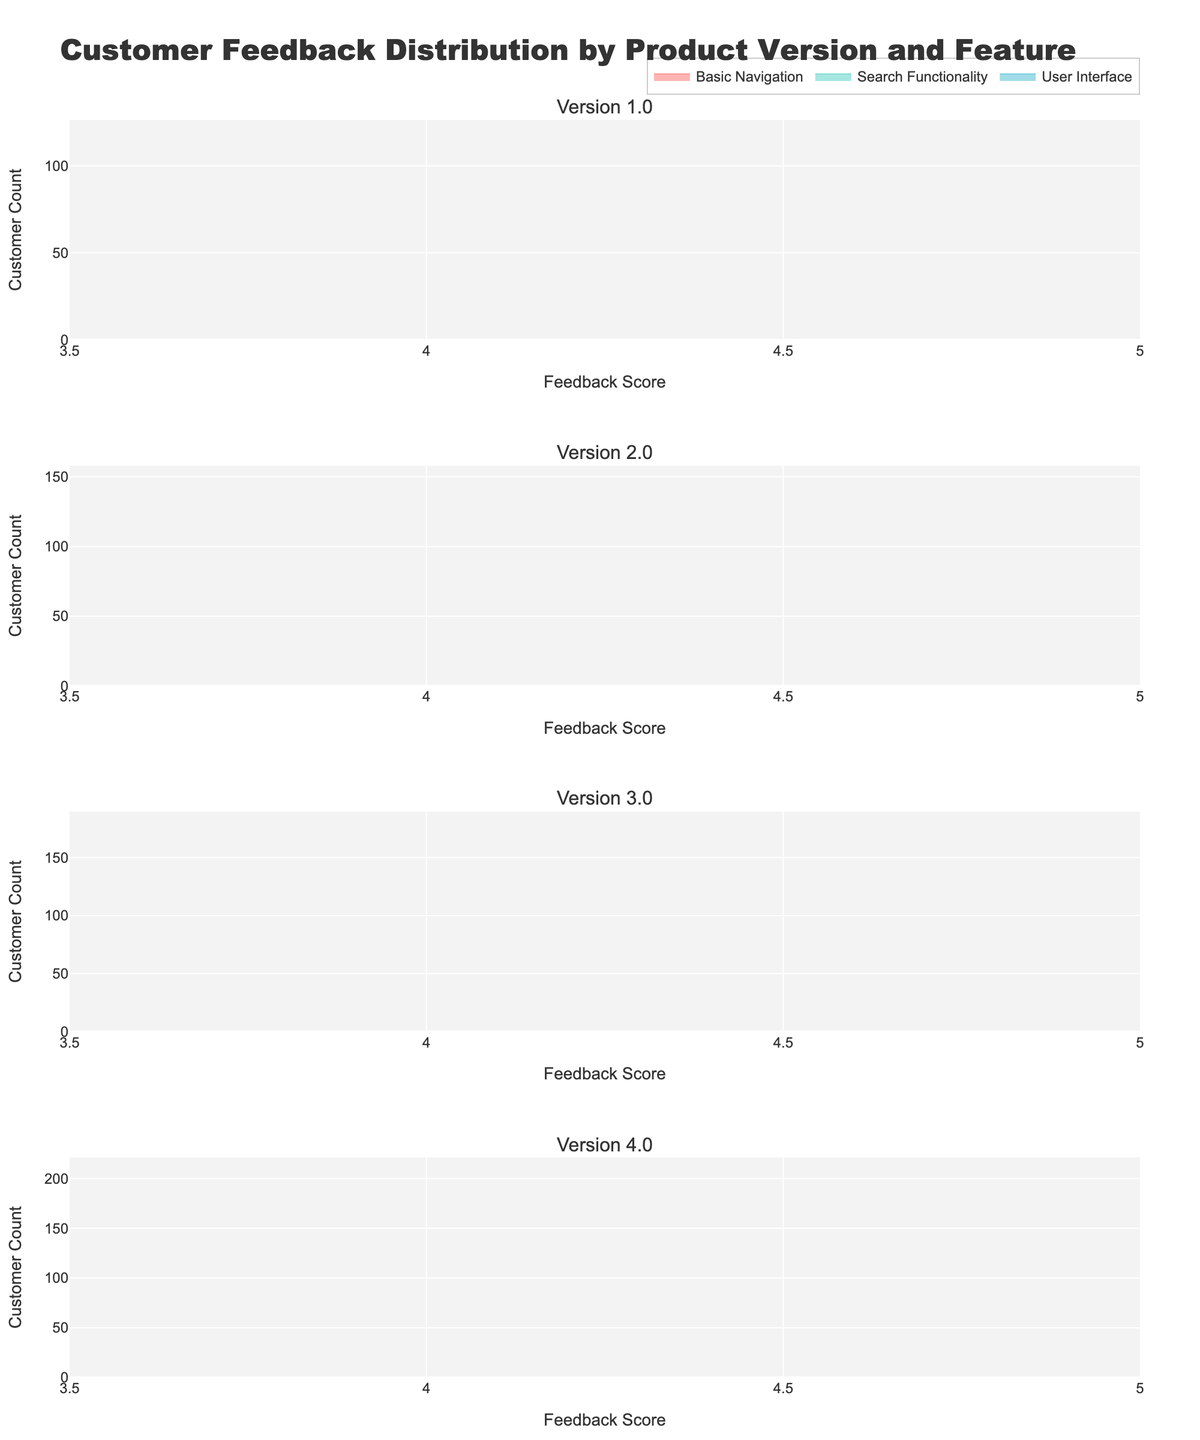What is the title of the figure? The title of the figure is usually located at the top of the plot. In this case, it is "Customer Feedback Distribution by Product Version and Feature".
Answer: Customer Feedback Distribution by Product Version and Feature How many subplots are there in the figure? Each product version has its own subplot, and we have versions 1.0, 2.0, 3.0, and 4.0. Counting these, we see there are four subplots.
Answer: 4 Which feature had the highest customer count in version 4.0? By looking at the subplot for version 4.0 and comparing the endpoints of each area chart representing the customer count, we see that the Search Functionality feature had the highest customer count.
Answer: Search Functionality What is the feedback score range displayed on the x-axis? The x-axis, which represents the feedback score, has labels indicating the range from 3.5 to 5.0.
Answer: 3.5 to 5.0 How does the feedback score for Basic Navigation compare between version 1.0 and version 4.0? In version 1.0, the feedback score for Basic Navigation is 4.5, while in version 4.0, it is 4.8. Thus, the feedback score increased from version 1.0 to version 4.0.
Answer: It increased Calculate the average feedback score of the User Interface feature across all versions. Add the feedback scores for User Interface in all versions (3.8, 4.1, 4.3, 4.7), then divide by the number of versions (4). (3.8 + 4.1 + 4.3 + 4.7) / 4 = 4.225
Answer: 4.225 Which feature showed up for the first time in version 3.0? By examining the features listed in versions 1.0 and 2.0 and comparing them with those in version 3.0, we find that AI Recommendations appeared for the first time in version 3.0.
Answer: AI Recommendations Does AI Recommendations in version 4.0 have a higher feedback score than Search Functionality in version 3.0? In version 4.0, AI Recommendations has a feedback score of 4.4. In version 3.0, Search Functionality has a feedback score of 4.5. Therefore, AI Recommendations in version 4.0 does not have a higher feedback score.
Answer: No Which feature has the most consistent feedback score across different versions? By observing the relative changes in feedback scores across versions, Basic Navigation remains consistently high with scores of 4.5, 4.7, 4.9, and 4.8, indicating a high level of consistency.
Answer: Basic Navigation 